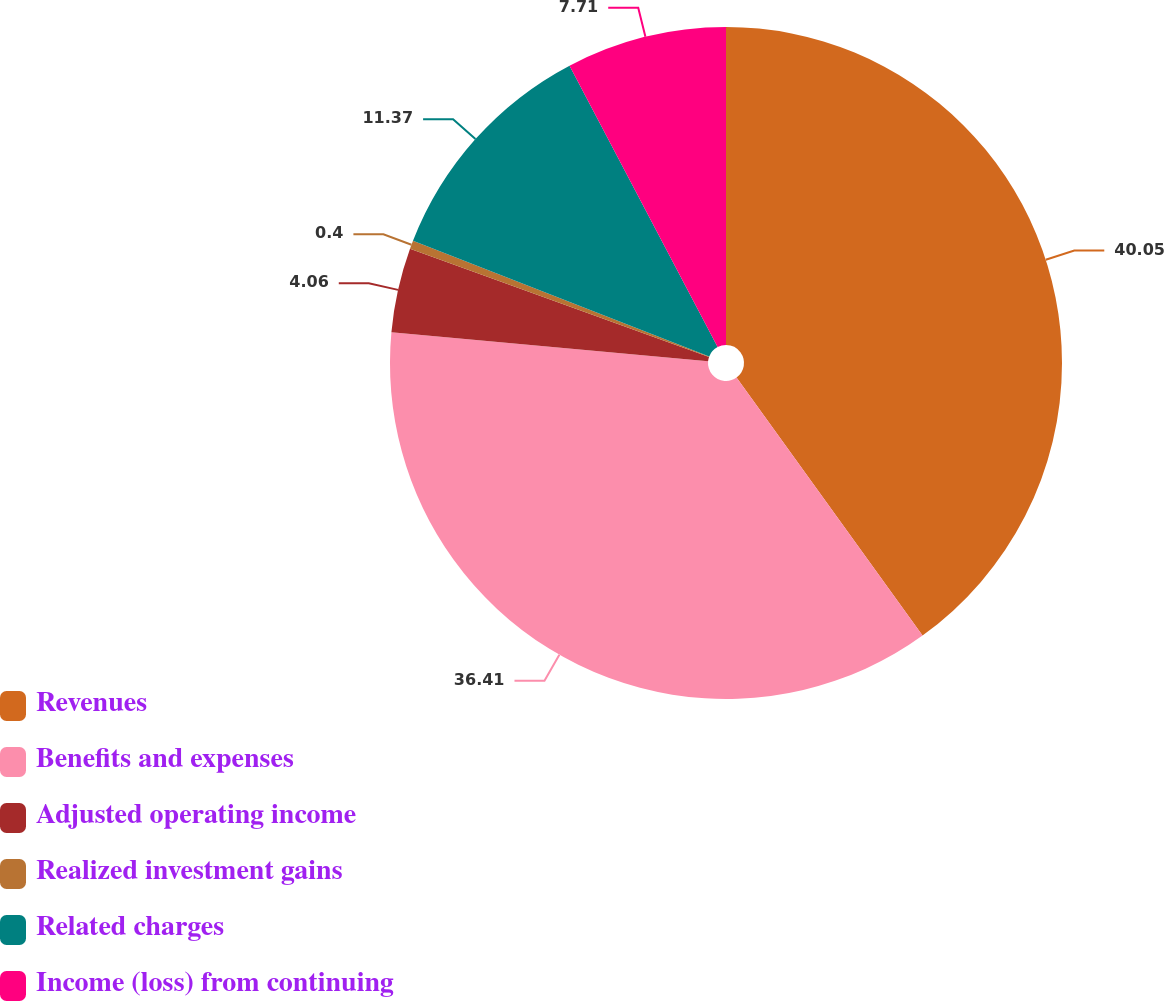Convert chart. <chart><loc_0><loc_0><loc_500><loc_500><pie_chart><fcel>Revenues<fcel>Benefits and expenses<fcel>Adjusted operating income<fcel>Realized investment gains<fcel>Related charges<fcel>Income (loss) from continuing<nl><fcel>40.06%<fcel>36.41%<fcel>4.06%<fcel>0.4%<fcel>11.37%<fcel>7.71%<nl></chart> 